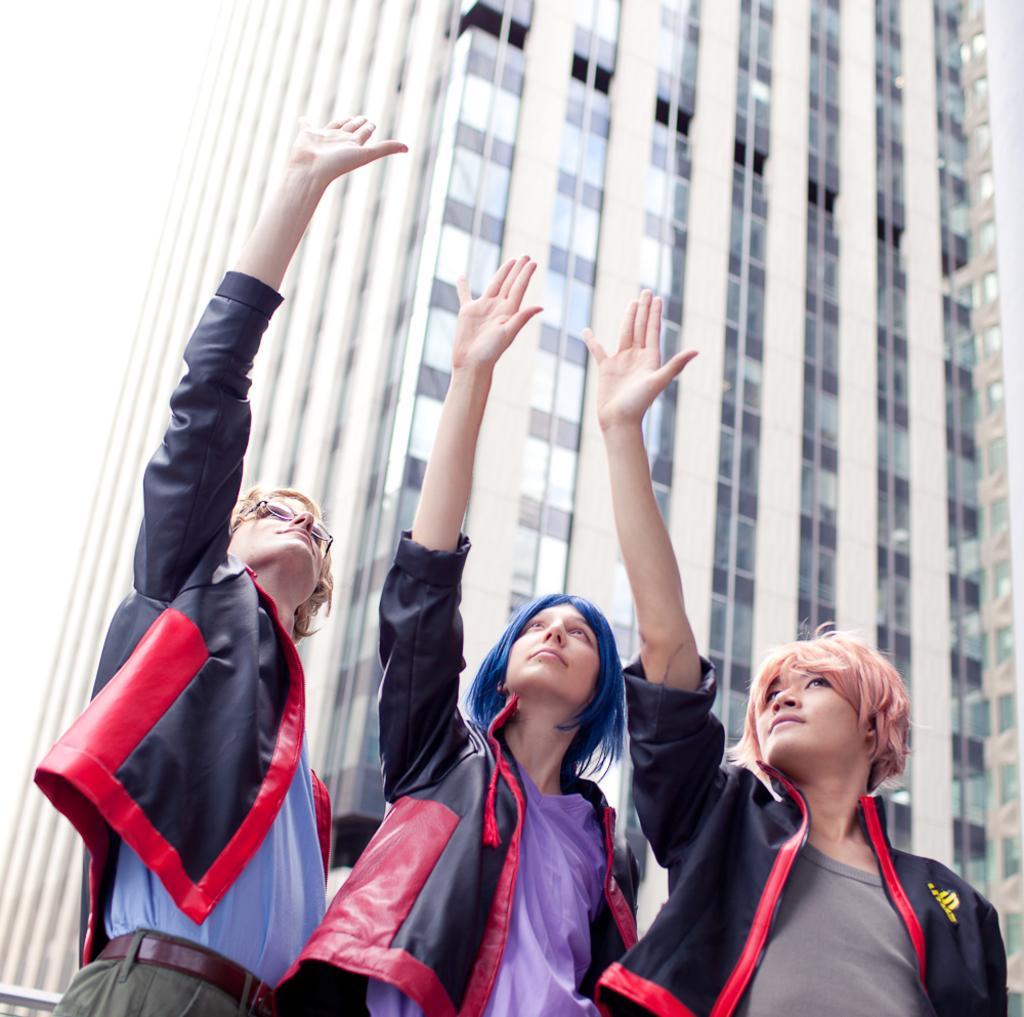In one or two sentences, can you explain what this image depicts? There are three people standing and raising hands. In the background we can see building. 